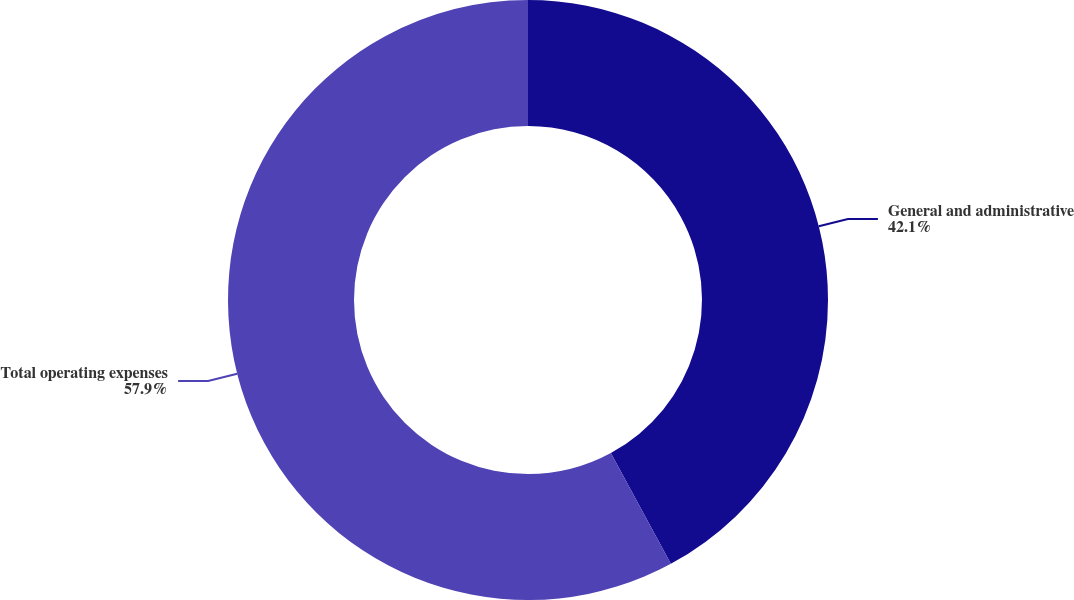Convert chart. <chart><loc_0><loc_0><loc_500><loc_500><pie_chart><fcel>General and administrative<fcel>Total operating expenses<nl><fcel>42.1%<fcel>57.9%<nl></chart> 